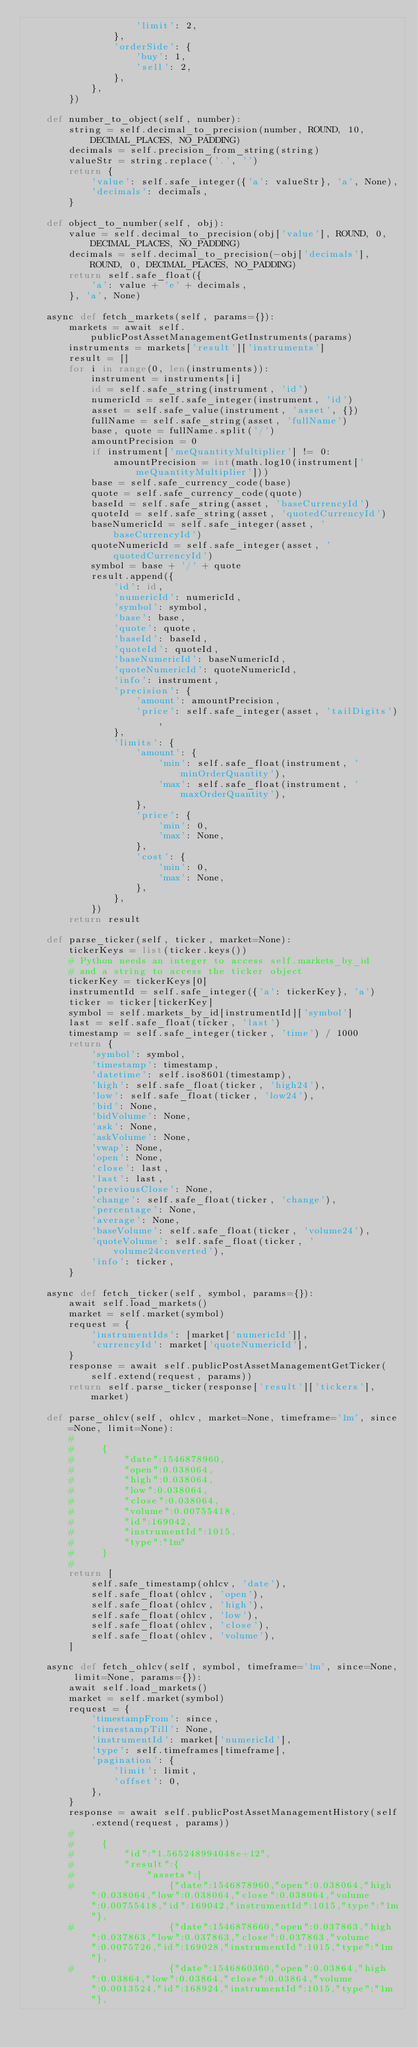<code> <loc_0><loc_0><loc_500><loc_500><_Python_>                    'limit': 2,
                },
                'orderSide': {
                    'buy': 1,
                    'sell': 2,
                },
            },
        })

    def number_to_object(self, number):
        string = self.decimal_to_precision(number, ROUND, 10, DECIMAL_PLACES, NO_PADDING)
        decimals = self.precision_from_string(string)
        valueStr = string.replace('.', '')
        return {
            'value': self.safe_integer({'a': valueStr}, 'a', None),
            'decimals': decimals,
        }

    def object_to_number(self, obj):
        value = self.decimal_to_precision(obj['value'], ROUND, 0, DECIMAL_PLACES, NO_PADDING)
        decimals = self.decimal_to_precision(-obj['decimals'], ROUND, 0, DECIMAL_PLACES, NO_PADDING)
        return self.safe_float({
            'a': value + 'e' + decimals,
        }, 'a', None)

    async def fetch_markets(self, params={}):
        markets = await self.publicPostAssetManagementGetInstruments(params)
        instruments = markets['result']['instruments']
        result = []
        for i in range(0, len(instruments)):
            instrument = instruments[i]
            id = self.safe_string(instrument, 'id')
            numericId = self.safe_integer(instrument, 'id')
            asset = self.safe_value(instrument, 'asset', {})
            fullName = self.safe_string(asset, 'fullName')
            base, quote = fullName.split('/')
            amountPrecision = 0
            if instrument['meQuantityMultiplier'] != 0:
                amountPrecision = int(math.log10(instrument['meQuantityMultiplier']))
            base = self.safe_currency_code(base)
            quote = self.safe_currency_code(quote)
            baseId = self.safe_string(asset, 'baseCurrencyId')
            quoteId = self.safe_string(asset, 'quotedCurrencyId')
            baseNumericId = self.safe_integer(asset, 'baseCurrencyId')
            quoteNumericId = self.safe_integer(asset, 'quotedCurrencyId')
            symbol = base + '/' + quote
            result.append({
                'id': id,
                'numericId': numericId,
                'symbol': symbol,
                'base': base,
                'quote': quote,
                'baseId': baseId,
                'quoteId': quoteId,
                'baseNumericId': baseNumericId,
                'quoteNumericId': quoteNumericId,
                'info': instrument,
                'precision': {
                    'amount': amountPrecision,
                    'price': self.safe_integer(asset, 'tailDigits'),
                },
                'limits': {
                    'amount': {
                        'min': self.safe_float(instrument, 'minOrderQuantity'),
                        'max': self.safe_float(instrument, 'maxOrderQuantity'),
                    },
                    'price': {
                        'min': 0,
                        'max': None,
                    },
                    'cost': {
                        'min': 0,
                        'max': None,
                    },
                },
            })
        return result

    def parse_ticker(self, ticker, market=None):
        tickerKeys = list(ticker.keys())
        # Python needs an integer to access self.markets_by_id
        # and a string to access the ticker object
        tickerKey = tickerKeys[0]
        instrumentId = self.safe_integer({'a': tickerKey}, 'a')
        ticker = ticker[tickerKey]
        symbol = self.markets_by_id[instrumentId]['symbol']
        last = self.safe_float(ticker, 'last')
        timestamp = self.safe_integer(ticker, 'time') / 1000
        return {
            'symbol': symbol,
            'timestamp': timestamp,
            'datetime': self.iso8601(timestamp),
            'high': self.safe_float(ticker, 'high24'),
            'low': self.safe_float(ticker, 'low24'),
            'bid': None,
            'bidVolume': None,
            'ask': None,
            'askVolume': None,
            'vwap': None,
            'open': None,
            'close': last,
            'last': last,
            'previousClose': None,
            'change': self.safe_float(ticker, 'change'),
            'percentage': None,
            'average': None,
            'baseVolume': self.safe_float(ticker, 'volume24'),
            'quoteVolume': self.safe_float(ticker, 'volume24converted'),
            'info': ticker,
        }

    async def fetch_ticker(self, symbol, params={}):
        await self.load_markets()
        market = self.market(symbol)
        request = {
            'instrumentIds': [market['numericId']],
            'currencyId': market['quoteNumericId'],
        }
        response = await self.publicPostAssetManagementGetTicker(self.extend(request, params))
        return self.parse_ticker(response['result']['tickers'], market)

    def parse_ohlcv(self, ohlcv, market=None, timeframe='1m', since=None, limit=None):
        #
        #     {
        #         "date":1546878960,
        #         "open":0.038064,
        #         "high":0.038064,
        #         "low":0.038064,
        #         "close":0.038064,
        #         "volume":0.00755418,
        #         "id":169042,
        #         "instrumentId":1015,
        #         "type":"1m"
        #     }
        #
        return [
            self.safe_timestamp(ohlcv, 'date'),
            self.safe_float(ohlcv, 'open'),
            self.safe_float(ohlcv, 'high'),
            self.safe_float(ohlcv, 'low'),
            self.safe_float(ohlcv, 'close'),
            self.safe_float(ohlcv, 'volume'),
        ]

    async def fetch_ohlcv(self, symbol, timeframe='1m', since=None, limit=None, params={}):
        await self.load_markets()
        market = self.market(symbol)
        request = {
            'timestampFrom': since,
            'timestampTill': None,
            'instrumentId': market['numericId'],
            'type': self.timeframes[timeframe],
            'pagination': {
                'limit': limit,
                'offset': 0,
            },
        }
        response = await self.publicPostAssetManagementHistory(self.extend(request, params))
        #
        #     {
        #         "id":"1.565248994048e+12",
        #         "result":{
        #             "assets":[
        #                 {"date":1546878960,"open":0.038064,"high":0.038064,"low":0.038064,"close":0.038064,"volume":0.00755418,"id":169042,"instrumentId":1015,"type":"1m"},
        #                 {"date":1546878660,"open":0.037863,"high":0.037863,"low":0.037863,"close":0.037863,"volume":0.0075726,"id":169028,"instrumentId":1015,"type":"1m"},
        #                 {"date":1546860360,"open":0.03864,"high":0.03864,"low":0.03864,"close":0.03864,"volume":0.0013524,"id":168924,"instrumentId":1015,"type":"1m"},</code> 